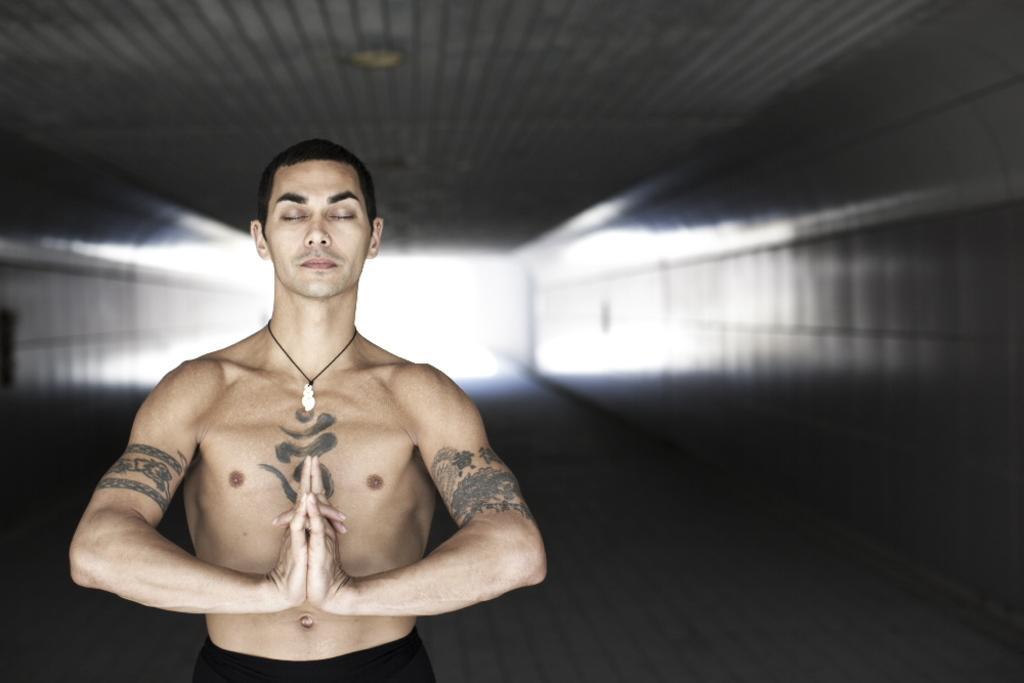Describe this image in one or two sentences. In this image we can see a man standing. In the background there is a wall. 